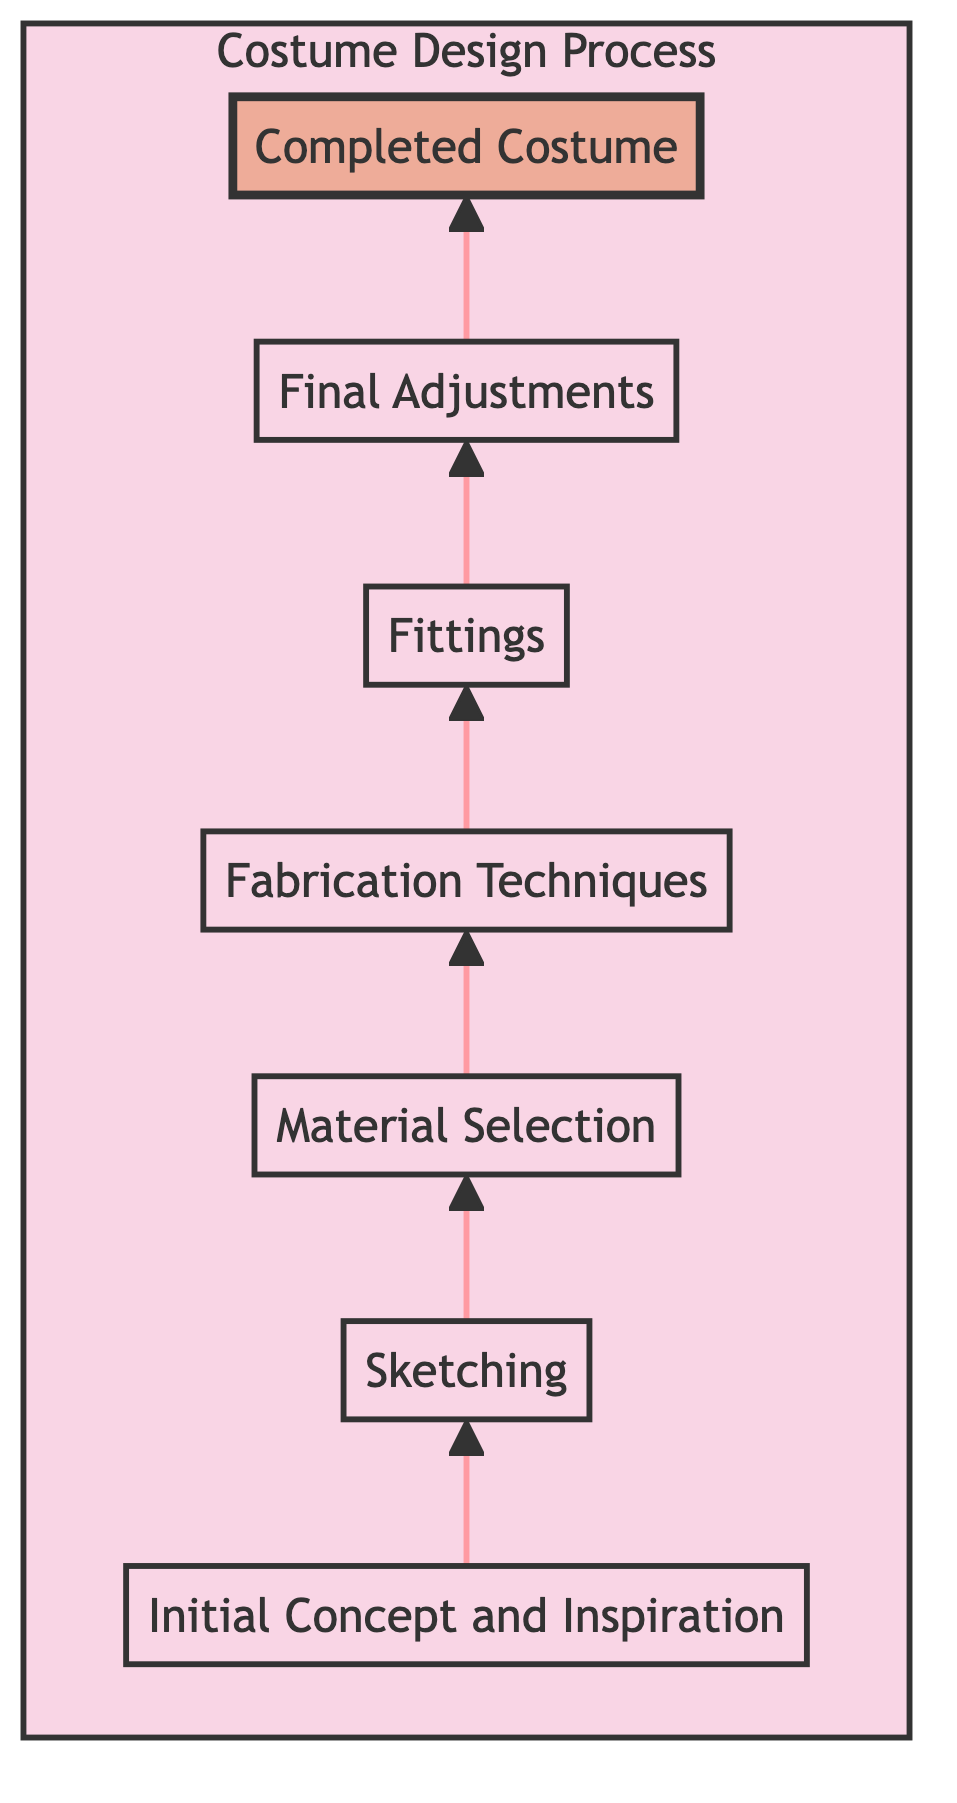What is the first stage in the costume design process? The diagram indicates that the first stage is "Initial Concept and Inspiration" at the bottom.
Answer: Initial Concept and Inspiration What follows sketching in the costume design process? After the "Sketching" stage, the next step is "Material Selection," which is represented directly above "Sketching."
Answer: Material Selection How many stages are there in the costume design process? By counting upward in the diagram, there are a total of 7 stages, including the "Completed Costume" stage at the top.
Answer: 7 What is the final stage of the costume design process? The topmost stage in the diagram is "Completed Costume," which is the last step before delivery to the client.
Answer: Completed Costume Which stage involves creating rough and detailed sketches? The stage that involves sketching is explicitly labeled "Sketching," where the designer creates various sketch types.
Answer: Sketching Which two stages are directly connected to the "Fittings" stage? "Fabrication Techniques" leads into "Fittings," and "Fittings" then connects upwards to "Final Adjustments," making these the two directly related stages.
Answer: Fabrication Techniques and Final Adjustments What stage requires customer interaction through fittings? The diagram shows that the "Fittings" stage is where interaction with the customer takes place to ensure proper fit and adjustments.
Answer: Fittings What is the primary purpose of the "Final Adjustments" stage? The "Final Adjustments" stage focuses on making necessary alterations based on feedback from the prior stage of "Fittings."
Answer: Necessary alterations What is the relationship between "Material Selection" and "Sketching"? "Material Selection" occurs after "Sketching," establishing that sketches inform the choice of materials used for the costume design.
Answer: Material Selection follows Sketching 